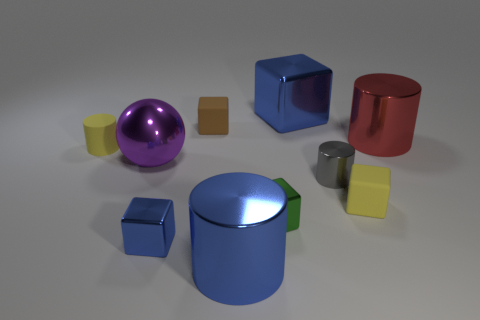What material is the big purple object?
Provide a short and direct response. Metal. Do the small thing in front of the small green shiny object and the big cylinder behind the large purple thing have the same material?
Your answer should be compact. Yes. What shape is the purple shiny object that is the same size as the red shiny cylinder?
Your response must be concise. Sphere. Are there fewer big cylinders than tiny cubes?
Keep it short and to the point. Yes. Are there any purple shiny things that are in front of the large cylinder that is behind the blue metal cylinder?
Provide a succinct answer. Yes. There is a small metallic cylinder that is behind the rubber object on the right side of the large blue cylinder; are there any red things in front of it?
Ensure brevity in your answer.  No. There is a large blue metal object that is in front of the purple thing; is it the same shape as the yellow object that is left of the small brown matte object?
Provide a short and direct response. Yes. The small cylinder that is the same material as the large purple object is what color?
Provide a succinct answer. Gray. Is the number of blue cylinders to the left of the big blue shiny cylinder less than the number of small purple shiny spheres?
Provide a succinct answer. No. There is a purple sphere left of the tiny metal object on the left side of the tiny rubber thing behind the big red cylinder; what size is it?
Your response must be concise. Large. 